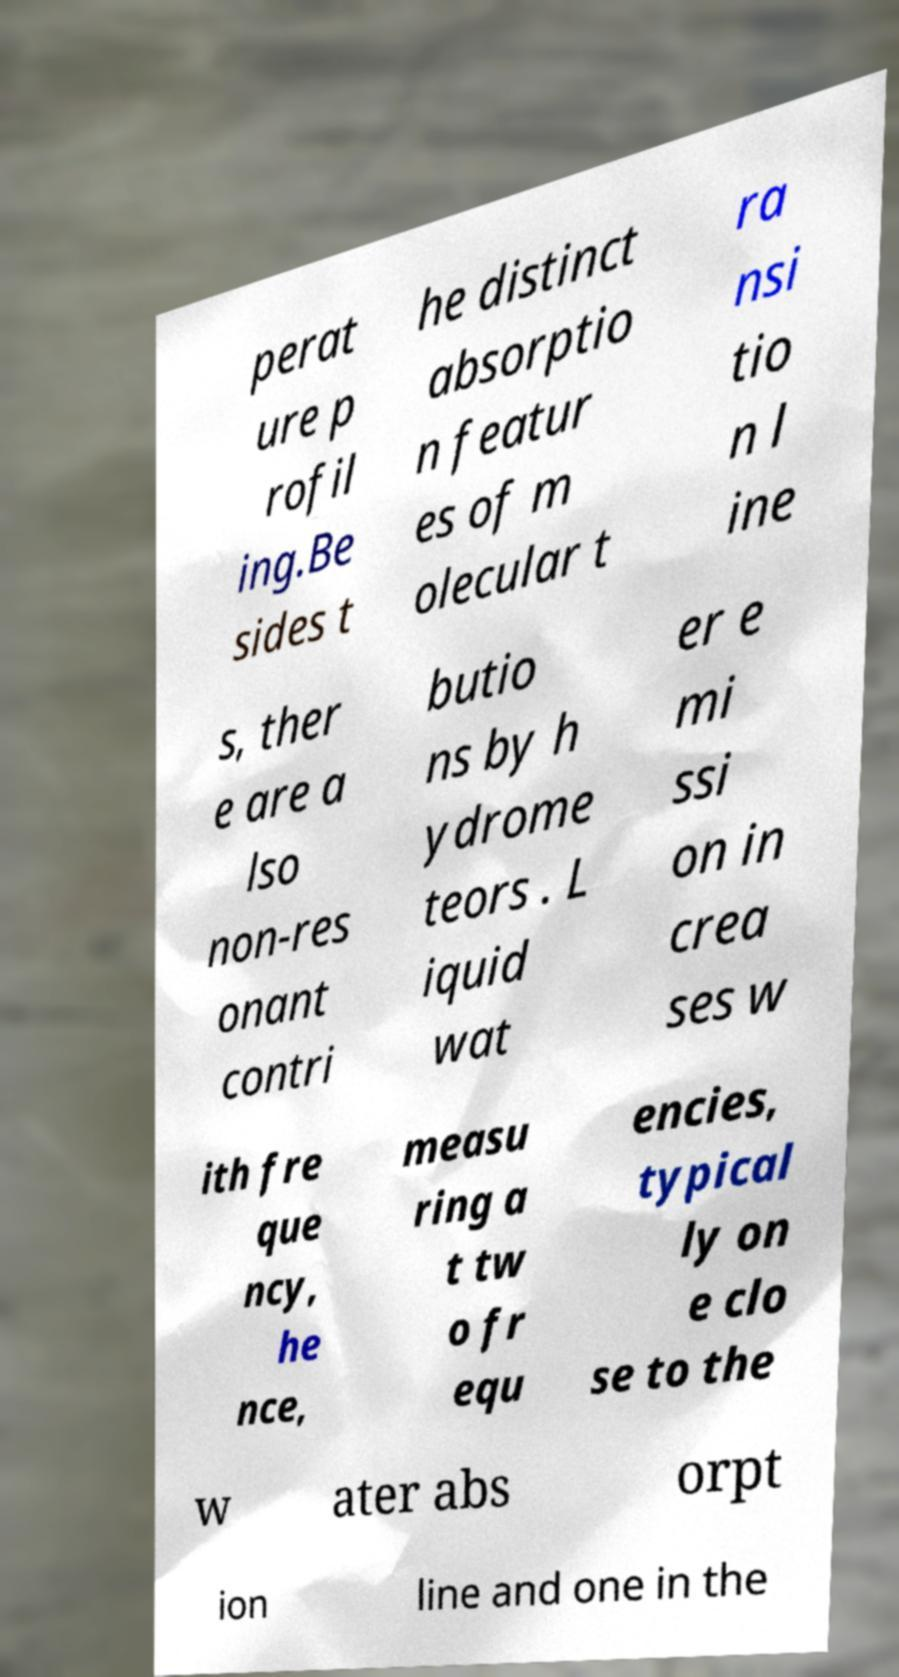Please read and relay the text visible in this image. What does it say? perat ure p rofil ing.Be sides t he distinct absorptio n featur es of m olecular t ra nsi tio n l ine s, ther e are a lso non-res onant contri butio ns by h ydrome teors . L iquid wat er e mi ssi on in crea ses w ith fre que ncy, he nce, measu ring a t tw o fr equ encies, typical ly on e clo se to the w ater abs orpt ion line and one in the 